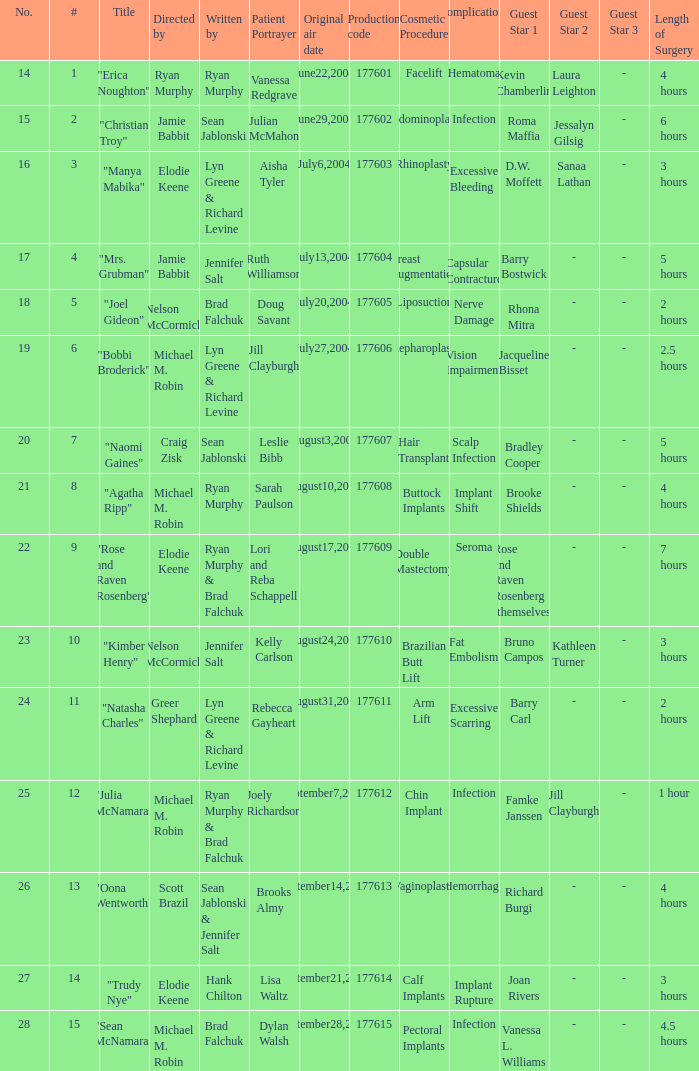Could you parse the entire table? {'header': ['No.', '#', 'Title', 'Directed by', 'Written by', 'Patient Portrayer', 'Original air date', 'Production code', 'Cosmetic Procedure', 'Complications', 'Guest Star 1', 'Guest Star 2', 'Guest Star 3', 'Length of Surgery'], 'rows': [['14', '1', '"Erica Noughton"', 'Ryan Murphy', 'Ryan Murphy', 'Vanessa Redgrave', 'June22,2004', '177601', 'Facelift', 'Hematoma', 'Kevin Chamberlin', 'Laura Leighton', '-', '4 hours'], ['15', '2', '"Christian Troy"', 'Jamie Babbit', 'Sean Jablonski', 'Julian McMahon', 'June29,2004', '177602', 'Abdominoplasty', 'Infection', 'Roma Maffia', 'Jessalyn Gilsig', '-', '6 hours'], ['16', '3', '"Manya Mabika"', 'Elodie Keene', 'Lyn Greene & Richard Levine', 'Aisha Tyler', 'July6,2004', '177603', 'Rhinoplasty', 'Excessive Bleeding', 'D.W. Moffett', 'Sanaa Lathan', '-', '3 hours'], ['17', '4', '"Mrs. Grubman"', 'Jamie Babbit', 'Jennifer Salt', 'Ruth Williamson', 'July13,2004', '177604', 'Breast Augmentation', 'Capsular Contracture', 'Barry Bostwick', '-', '-', '5 hours'], ['18', '5', '"Joel Gideon"', 'Nelson McCormick', 'Brad Falchuk', 'Doug Savant', 'July20,2004', '177605', 'Liposuction', 'Nerve Damage', 'Rhona Mitra', '-', '-', '2 hours'], ['19', '6', '"Bobbi Broderick"', 'Michael M. Robin', 'Lyn Greene & Richard Levine', 'Jill Clayburgh', 'July27,2004', '177606', 'Blepharoplasty', 'Vision Impairment', 'Jacqueline Bisset', '-', '-', '2.5 hours'], ['20', '7', '"Naomi Gaines"', 'Craig Zisk', 'Sean Jablonski', 'Leslie Bibb', 'August3,2004', '177607', 'Hair Transplant', 'Scalp Infection', 'Bradley Cooper', '-', '-', '5 hours'], ['21', '8', '"Agatha Ripp"', 'Michael M. Robin', 'Ryan Murphy', 'Sarah Paulson', 'August10,2004', '177608', 'Buttock Implants', 'Implant Shift', 'Brooke Shields', '-', '-', '4 hours'], ['22', '9', '"Rose and Raven Rosenberg"', 'Elodie Keene', 'Ryan Murphy & Brad Falchuk', 'Lori and Reba Schappell', 'August17,2004', '177609', 'Double Mastectomy', 'Seroma', 'Rose and Raven Rosenberg (themselves)', '-', '-', '7 hours'], ['23', '10', '"Kimber Henry"', 'Nelson McCormick', 'Jennifer Salt', 'Kelly Carlson', 'August24,2004', '177610', 'Brazilian Butt Lift', 'Fat Embolism', 'Bruno Campos', 'Kathleen Turner', '-', '3 hours'], ['24', '11', '"Natasha Charles"', 'Greer Shephard', 'Lyn Greene & Richard Levine', 'Rebecca Gayheart', 'August31,2004', '177611', 'Arm Lift', 'Excessive Scarring', 'Barry Carl', '-', '-', '2 hours'], ['25', '12', '"Julia McNamara"', 'Michael M. Robin', 'Ryan Murphy & Brad Falchuk', 'Joely Richardson', 'September7,2004', '177612', 'Chin Implant', 'Infection', 'Famke Janssen', 'Jill Clayburgh', '-', '1 hour'], ['26', '13', '"Oona Wentworth"', 'Scott Brazil', 'Sean Jablonski & Jennifer Salt', 'Brooks Almy', 'September14,2004', '177613', 'Vaginoplasty', 'Hemorrhage', 'Richard Burgi', '-', '-', '4 hours'], ['27', '14', '"Trudy Nye"', 'Elodie Keene', 'Hank Chilton', 'Lisa Waltz', 'September21,2004', '177614', 'Calf Implants', 'Implant Rupture', 'Joan Rivers', '-', '-', '3 hours'], ['28', '15', '"Sean McNamara"', 'Michael M. Robin', 'Brad Falchuk', 'Dylan Walsh', 'September28,2004', '177615', 'Pectoral Implants', 'Infection', 'Vanessa L. Williams', '-', '-', '4.5 hours']]} How many episodes are numbered 4 in the season? 1.0. 